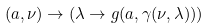Convert formula to latex. <formula><loc_0><loc_0><loc_500><loc_500>( a , \nu ) \rightarrow ( \lambda \rightarrow g ( a , \gamma ( \nu , \lambda ) ) )</formula> 